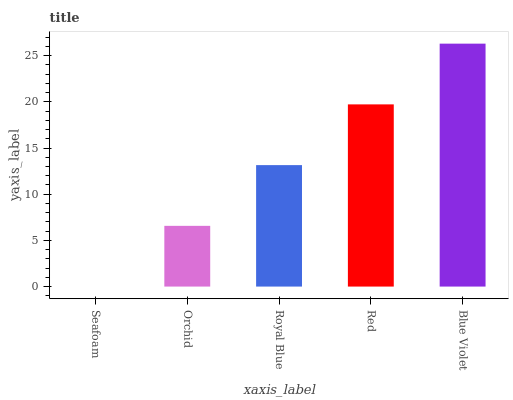Is Seafoam the minimum?
Answer yes or no. Yes. Is Blue Violet the maximum?
Answer yes or no. Yes. Is Orchid the minimum?
Answer yes or no. No. Is Orchid the maximum?
Answer yes or no. No. Is Orchid greater than Seafoam?
Answer yes or no. Yes. Is Seafoam less than Orchid?
Answer yes or no. Yes. Is Seafoam greater than Orchid?
Answer yes or no. No. Is Orchid less than Seafoam?
Answer yes or no. No. Is Royal Blue the high median?
Answer yes or no. Yes. Is Royal Blue the low median?
Answer yes or no. Yes. Is Seafoam the high median?
Answer yes or no. No. Is Orchid the low median?
Answer yes or no. No. 